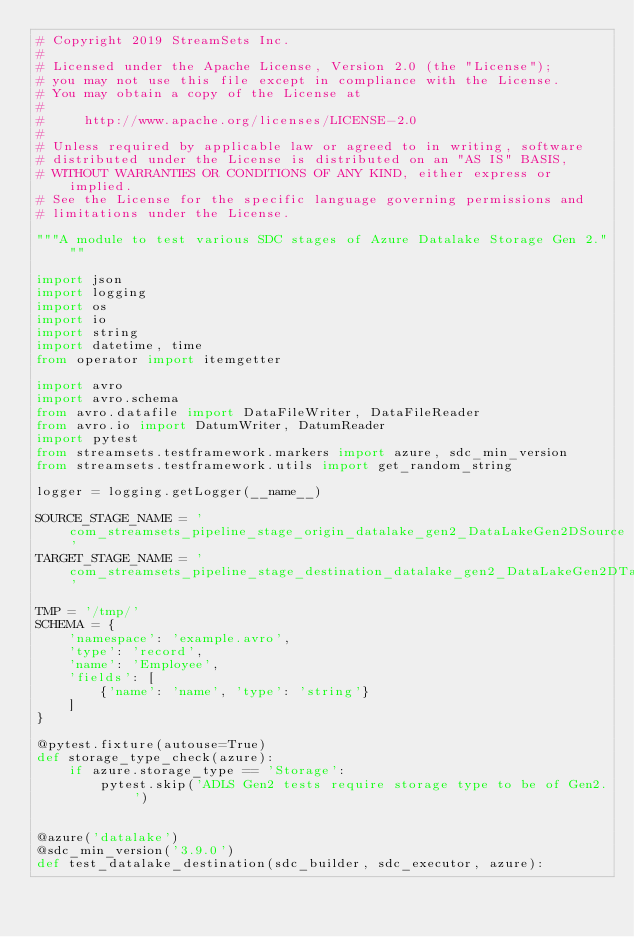Convert code to text. <code><loc_0><loc_0><loc_500><loc_500><_Python_># Copyright 2019 StreamSets Inc.
#
# Licensed under the Apache License, Version 2.0 (the "License");
# you may not use this file except in compliance with the License.
# You may obtain a copy of the License at
#
#     http://www.apache.org/licenses/LICENSE-2.0
#
# Unless required by applicable law or agreed to in writing, software
# distributed under the License is distributed on an "AS IS" BASIS,
# WITHOUT WARRANTIES OR CONDITIONS OF ANY KIND, either express or implied.
# See the License for the specific language governing permissions and
# limitations under the License.

"""A module to test various SDC stages of Azure Datalake Storage Gen 2."""

import json
import logging
import os
import io
import string
import datetime, time
from operator import itemgetter

import avro
import avro.schema
from avro.datafile import DataFileWriter, DataFileReader
from avro.io import DatumWriter, DatumReader
import pytest
from streamsets.testframework.markers import azure, sdc_min_version
from streamsets.testframework.utils import get_random_string

logger = logging.getLogger(__name__)

SOURCE_STAGE_NAME = 'com_streamsets_pipeline_stage_origin_datalake_gen2_DataLakeGen2DSource'
TARGET_STAGE_NAME = 'com_streamsets_pipeline_stage_destination_datalake_gen2_DataLakeGen2DTarget'

TMP = '/tmp/'
SCHEMA = {
    'namespace': 'example.avro',
    'type': 'record',
    'name': 'Employee',
    'fields': [
        {'name': 'name', 'type': 'string'}
    ]
}

@pytest.fixture(autouse=True)
def storage_type_check(azure):
    if azure.storage_type == 'Storage':
        pytest.skip('ADLS Gen2 tests require storage type to be of Gen2.')


@azure('datalake')
@sdc_min_version('3.9.0')
def test_datalake_destination(sdc_builder, sdc_executor, azure):</code> 